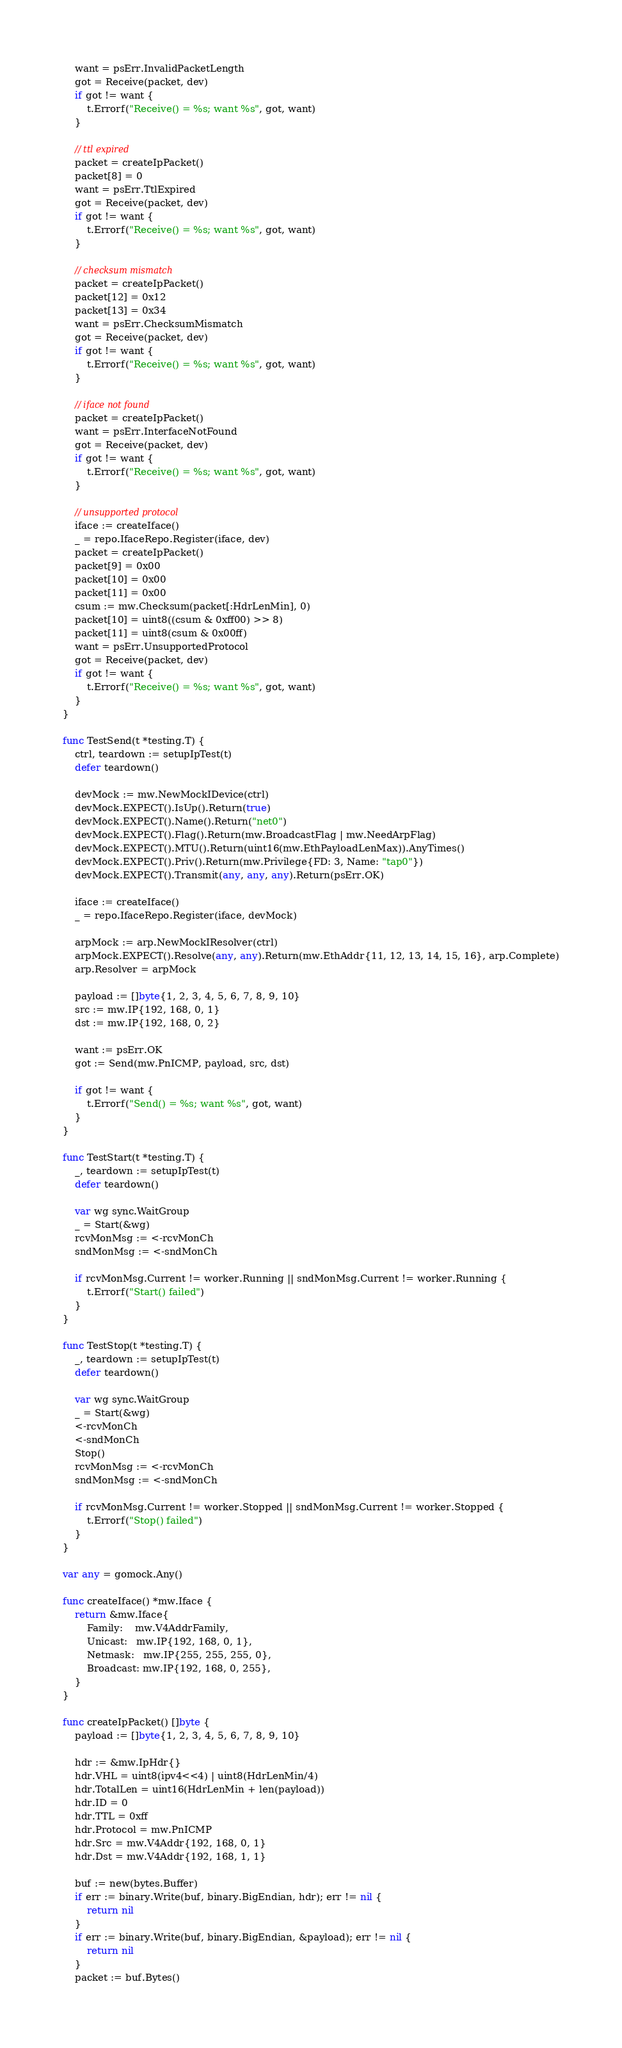<code> <loc_0><loc_0><loc_500><loc_500><_Go_>	want = psErr.InvalidPacketLength
	got = Receive(packet, dev)
	if got != want {
		t.Errorf("Receive() = %s; want %s", got, want)
	}

	// ttl expired
	packet = createIpPacket()
	packet[8] = 0
	want = psErr.TtlExpired
	got = Receive(packet, dev)
	if got != want {
		t.Errorf("Receive() = %s; want %s", got, want)
	}

	// checksum mismatch
	packet = createIpPacket()
	packet[12] = 0x12
	packet[13] = 0x34
	want = psErr.ChecksumMismatch
	got = Receive(packet, dev)
	if got != want {
		t.Errorf("Receive() = %s; want %s", got, want)
	}

	// iface not found
	packet = createIpPacket()
	want = psErr.InterfaceNotFound
	got = Receive(packet, dev)
	if got != want {
		t.Errorf("Receive() = %s; want %s", got, want)
	}

	// unsupported protocol
	iface := createIface()
	_ = repo.IfaceRepo.Register(iface, dev)
	packet = createIpPacket()
	packet[9] = 0x00
	packet[10] = 0x00
	packet[11] = 0x00
	csum := mw.Checksum(packet[:HdrLenMin], 0)
	packet[10] = uint8((csum & 0xff00) >> 8)
	packet[11] = uint8(csum & 0x00ff)
	want = psErr.UnsupportedProtocol
	got = Receive(packet, dev)
	if got != want {
		t.Errorf("Receive() = %s; want %s", got, want)
	}
}

func TestSend(t *testing.T) {
	ctrl, teardown := setupIpTest(t)
	defer teardown()

	devMock := mw.NewMockIDevice(ctrl)
	devMock.EXPECT().IsUp().Return(true)
	devMock.EXPECT().Name().Return("net0")
	devMock.EXPECT().Flag().Return(mw.BroadcastFlag | mw.NeedArpFlag)
	devMock.EXPECT().MTU().Return(uint16(mw.EthPayloadLenMax)).AnyTimes()
	devMock.EXPECT().Priv().Return(mw.Privilege{FD: 3, Name: "tap0"})
	devMock.EXPECT().Transmit(any, any, any).Return(psErr.OK)

	iface := createIface()
	_ = repo.IfaceRepo.Register(iface, devMock)

	arpMock := arp.NewMockIResolver(ctrl)
	arpMock.EXPECT().Resolve(any, any).Return(mw.EthAddr{11, 12, 13, 14, 15, 16}, arp.Complete)
	arp.Resolver = arpMock

	payload := []byte{1, 2, 3, 4, 5, 6, 7, 8, 9, 10}
	src := mw.IP{192, 168, 0, 1}
	dst := mw.IP{192, 168, 0, 2}

	want := psErr.OK
	got := Send(mw.PnICMP, payload, src, dst)

	if got != want {
		t.Errorf("Send() = %s; want %s", got, want)
	}
}

func TestStart(t *testing.T) {
	_, teardown := setupIpTest(t)
	defer teardown()

	var wg sync.WaitGroup
	_ = Start(&wg)
	rcvMonMsg := <-rcvMonCh
	sndMonMsg := <-sndMonCh

	if rcvMonMsg.Current != worker.Running || sndMonMsg.Current != worker.Running {
		t.Errorf("Start() failed")
	}
}

func TestStop(t *testing.T) {
	_, teardown := setupIpTest(t)
	defer teardown()

	var wg sync.WaitGroup
	_ = Start(&wg)
	<-rcvMonCh
	<-sndMonCh
	Stop()
	rcvMonMsg := <-rcvMonCh
	sndMonMsg := <-sndMonCh

	if rcvMonMsg.Current != worker.Stopped || sndMonMsg.Current != worker.Stopped {
		t.Errorf("Stop() failed")
	}
}

var any = gomock.Any()

func createIface() *mw.Iface {
	return &mw.Iface{
		Family:    mw.V4AddrFamily,
		Unicast:   mw.IP{192, 168, 0, 1},
		Netmask:   mw.IP{255, 255, 255, 0},
		Broadcast: mw.IP{192, 168, 0, 255},
	}
}

func createIpPacket() []byte {
	payload := []byte{1, 2, 3, 4, 5, 6, 7, 8, 9, 10}

	hdr := &mw.IpHdr{}
	hdr.VHL = uint8(ipv4<<4) | uint8(HdrLenMin/4)
	hdr.TotalLen = uint16(HdrLenMin + len(payload))
	hdr.ID = 0
	hdr.TTL = 0xff
	hdr.Protocol = mw.PnICMP
	hdr.Src = mw.V4Addr{192, 168, 0, 1}
	hdr.Dst = mw.V4Addr{192, 168, 1, 1}

	buf := new(bytes.Buffer)
	if err := binary.Write(buf, binary.BigEndian, hdr); err != nil {
		return nil
	}
	if err := binary.Write(buf, binary.BigEndian, &payload); err != nil {
		return nil
	}
	packet := buf.Bytes()
</code> 